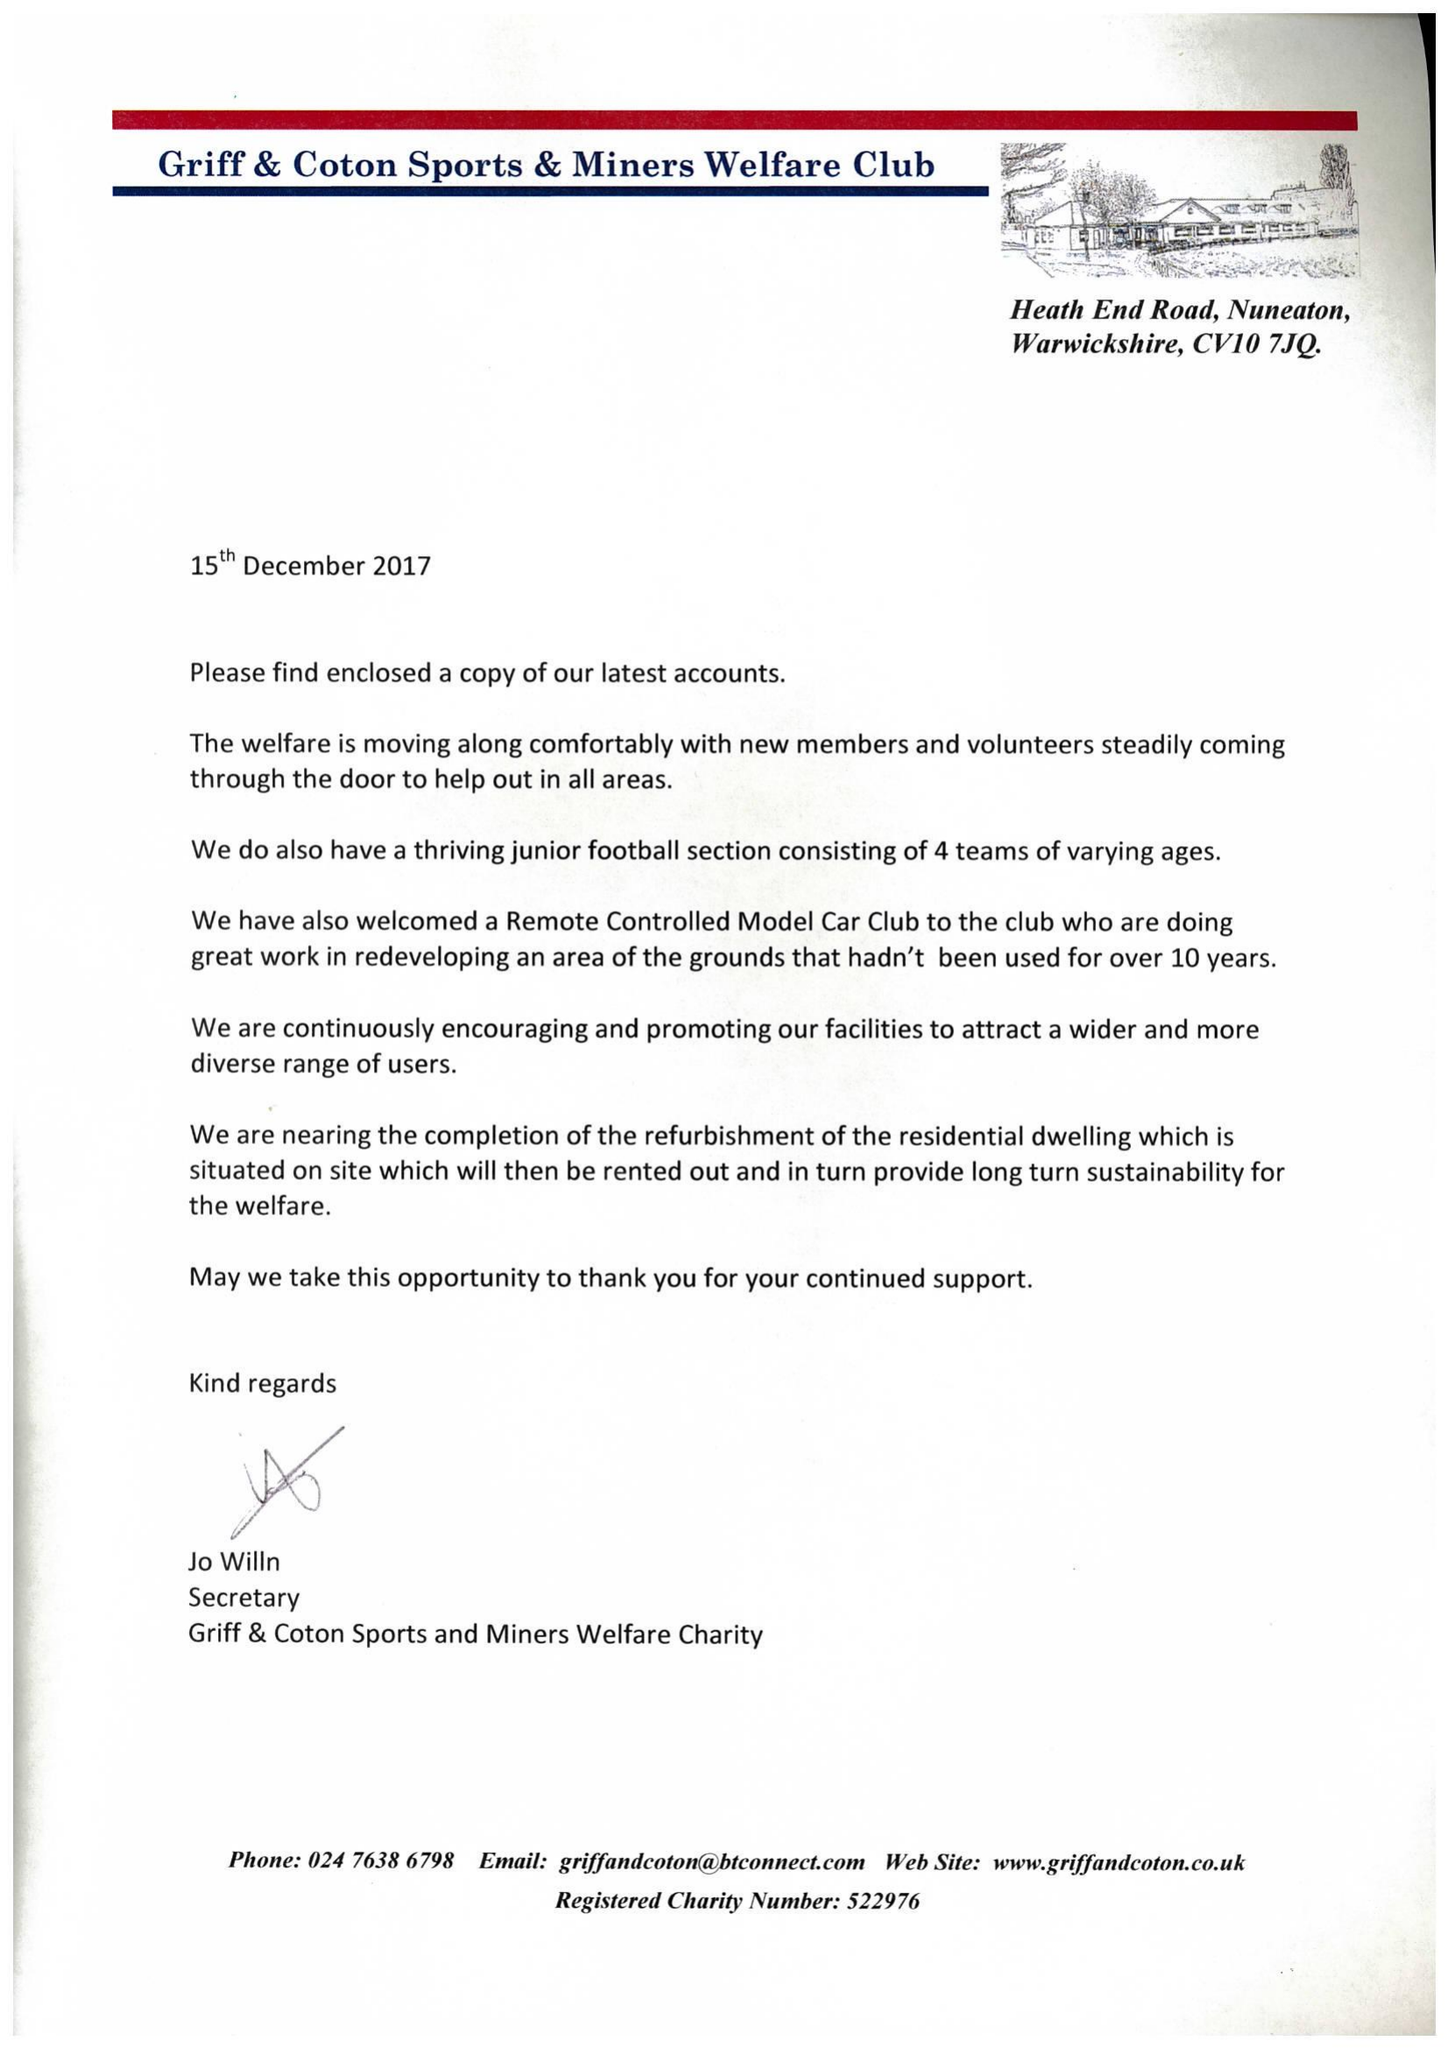What is the value for the address__postcode?
Answer the question using a single word or phrase. CV10 7JQ 